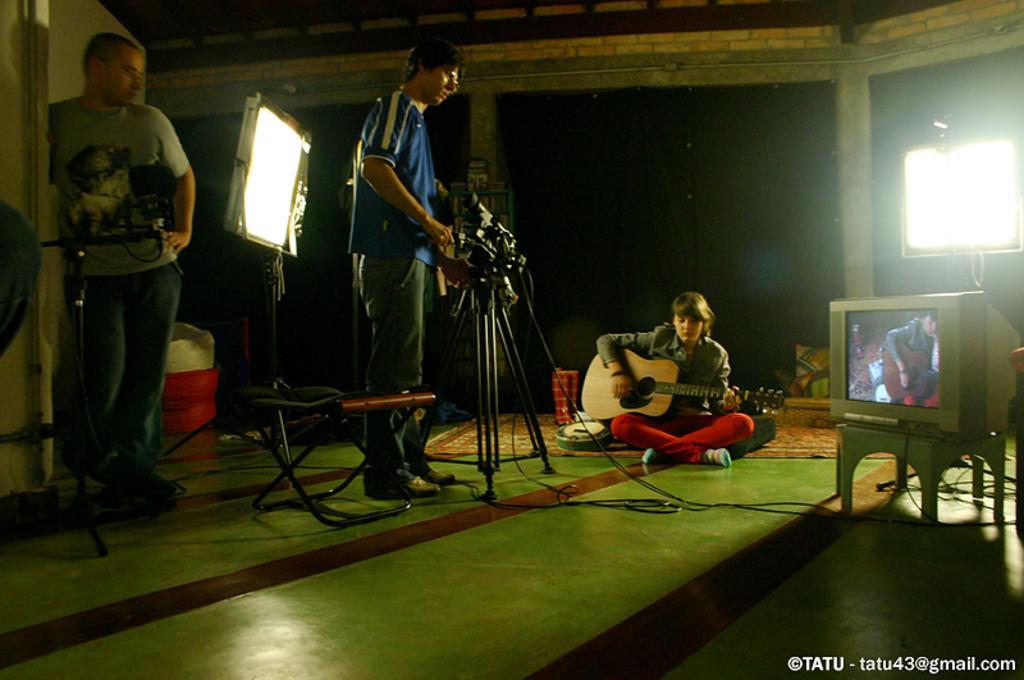How would you summarize this image in a sentence or two? In this image i can see a person wearing blue t shirt and jeans standing and holding the camera. I can see a woman sitting on the floor and holding a guitar in her hand to the left of the image i can see a person standing ,a microphone and a light and to the right of the image i can see a television screen. In the background i can see few pillars the wall and the light. 